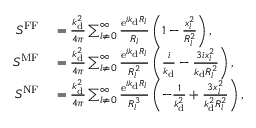<formula> <loc_0><loc_0><loc_500><loc_500>\begin{array} { r l } { S ^ { F F } } & = \frac { k _ { d } ^ { 2 } } { 4 \pi } \sum _ { l \neq 0 } ^ { \infty } \frac { e ^ { i k _ { d } R _ { l } } } { R _ { l } } \left ( 1 - \frac { x _ { l } ^ { 2 } } { R _ { l } ^ { 2 } } \right ) , } \\ { S ^ { M F } } & = \frac { k _ { d } ^ { 2 } } { 4 \pi } \sum _ { l \neq 0 } ^ { \infty } \frac { e ^ { i k _ { d } R _ { l } } } { R _ { l } ^ { 2 } } \left ( \frac { i } { k _ { d } } - \frac { 3 i x _ { l } ^ { 2 } } { k _ { d } R _ { l } ^ { 2 } } \right ) , } \\ { S ^ { N F } } & = \frac { k _ { d } ^ { 2 } } { 4 \pi } \sum _ { l \neq 0 } ^ { \infty } \frac { e ^ { i k _ { d } R _ { l } } } { R _ { l } ^ { 3 } } \left ( - \frac { 1 } { k _ { d } ^ { 2 } } + \frac { 3 x _ { l } ^ { 2 } } { k _ { d } ^ { 2 } R _ { l } ^ { 2 } } \right ) , } \end{array}</formula> 